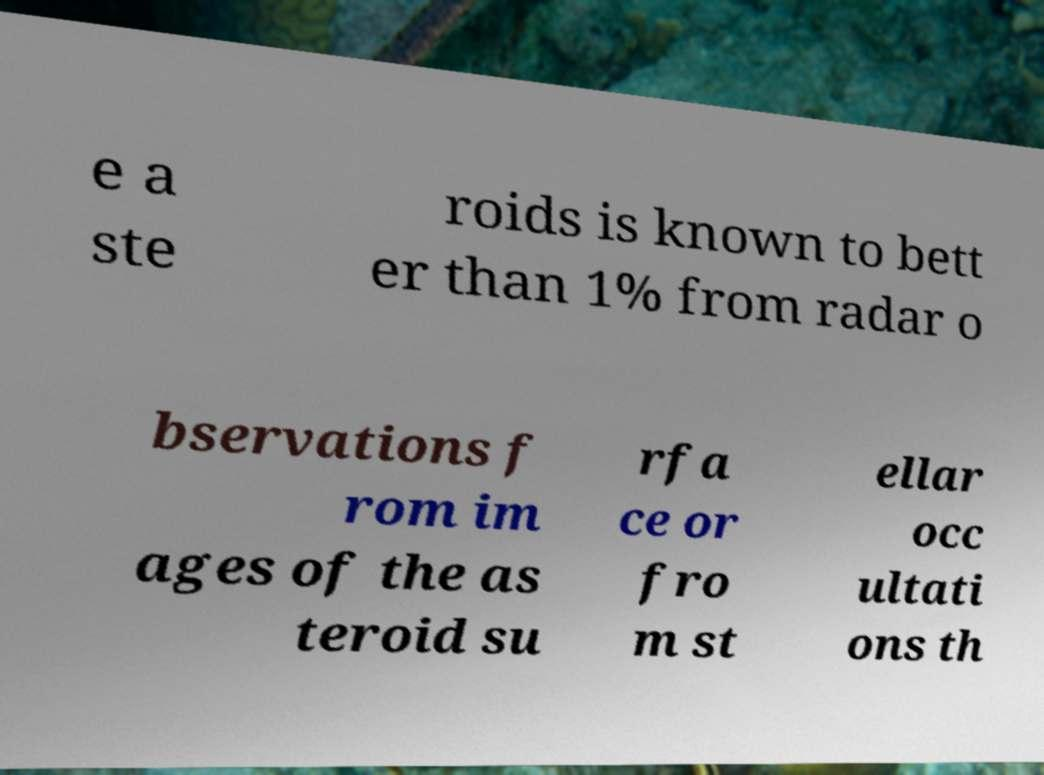Can you read and provide the text displayed in the image?This photo seems to have some interesting text. Can you extract and type it out for me? e a ste roids is known to bett er than 1% from radar o bservations f rom im ages of the as teroid su rfa ce or fro m st ellar occ ultati ons th 